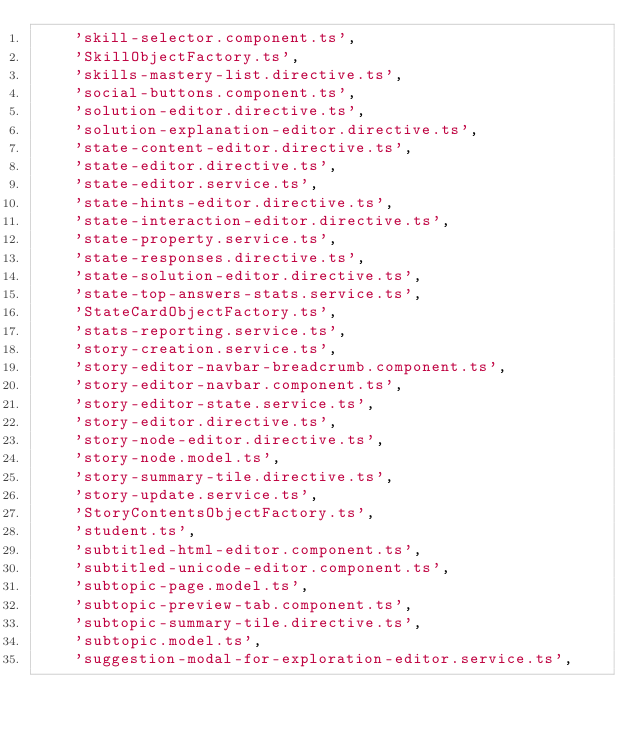Convert code to text. <code><loc_0><loc_0><loc_500><loc_500><_Python_>    'skill-selector.component.ts',
    'SkillObjectFactory.ts',
    'skills-mastery-list.directive.ts',
    'social-buttons.component.ts',
    'solution-editor.directive.ts',
    'solution-explanation-editor.directive.ts',
    'state-content-editor.directive.ts',
    'state-editor.directive.ts',
    'state-editor.service.ts',
    'state-hints-editor.directive.ts',
    'state-interaction-editor.directive.ts',
    'state-property.service.ts',
    'state-responses.directive.ts',
    'state-solution-editor.directive.ts',
    'state-top-answers-stats.service.ts',
    'StateCardObjectFactory.ts',
    'stats-reporting.service.ts',
    'story-creation.service.ts',
    'story-editor-navbar-breadcrumb.component.ts',
    'story-editor-navbar.component.ts',
    'story-editor-state.service.ts',
    'story-editor.directive.ts',
    'story-node-editor.directive.ts',
    'story-node.model.ts',
    'story-summary-tile.directive.ts',
    'story-update.service.ts',
    'StoryContentsObjectFactory.ts',
    'student.ts',
    'subtitled-html-editor.component.ts',
    'subtitled-unicode-editor.component.ts',
    'subtopic-page.model.ts',
    'subtopic-preview-tab.component.ts',
    'subtopic-summary-tile.directive.ts',
    'subtopic.model.ts',
    'suggestion-modal-for-exploration-editor.service.ts',</code> 